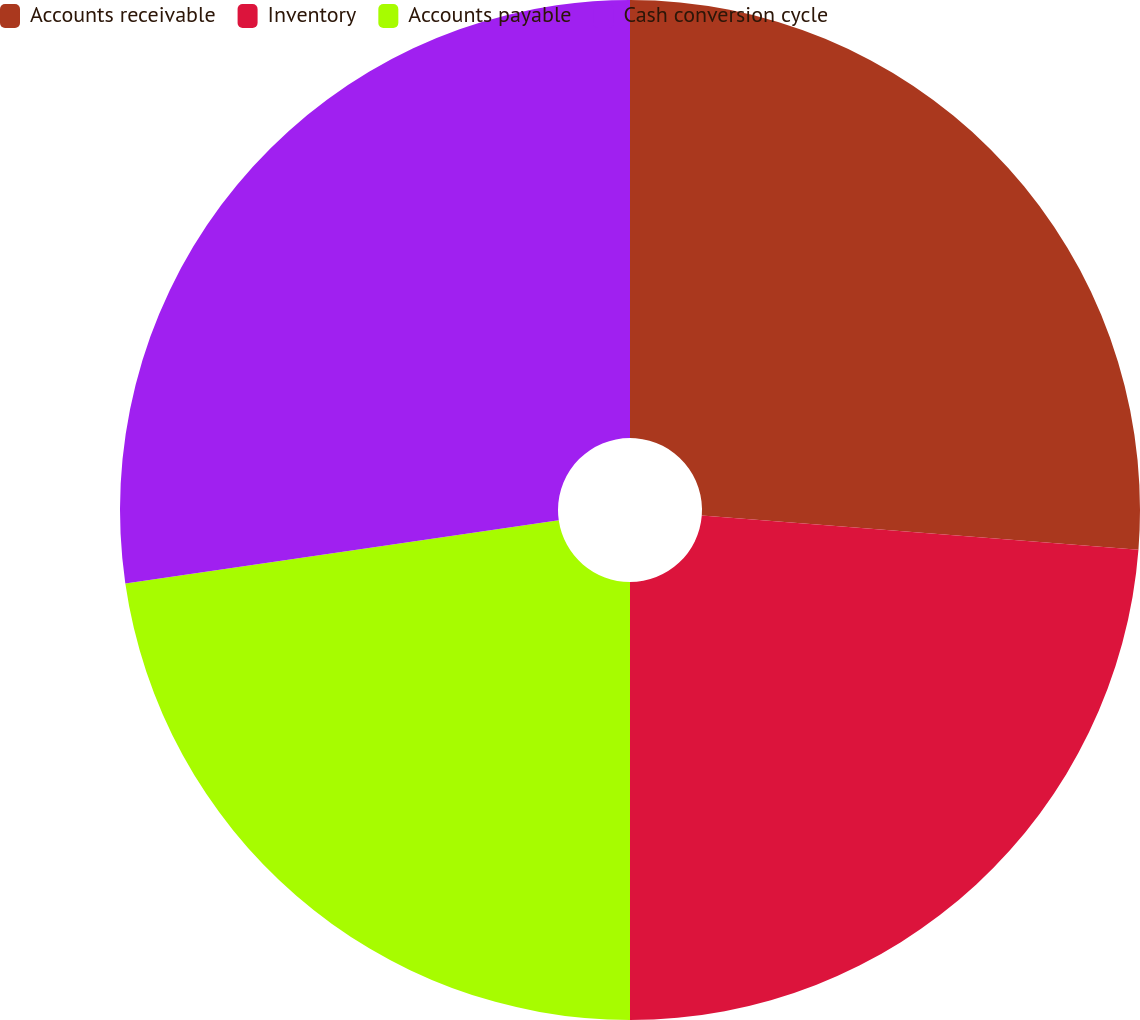Convert chart to OTSL. <chart><loc_0><loc_0><loc_500><loc_500><pie_chart><fcel>Accounts receivable<fcel>Inventory<fcel>Accounts payable<fcel>Cash conversion cycle<nl><fcel>26.24%<fcel>23.76%<fcel>22.7%<fcel>27.3%<nl></chart> 